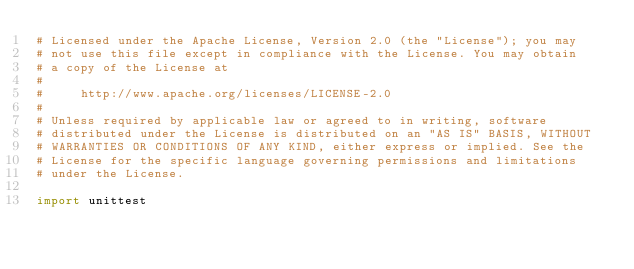Convert code to text. <code><loc_0><loc_0><loc_500><loc_500><_Python_># Licensed under the Apache License, Version 2.0 (the "License"); you may
# not use this file except in compliance with the License. You may obtain
# a copy of the License at
#
#     http://www.apache.org/licenses/LICENSE-2.0
#
# Unless required by applicable law or agreed to in writing, software
# distributed under the License is distributed on an "AS IS" BASIS, WITHOUT
# WARRANTIES OR CONDITIONS OF ANY KIND, either express or implied. See the
# License for the specific language governing permissions and limitations
# under the License.

import unittest
</code> 